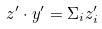Convert formula to latex. <formula><loc_0><loc_0><loc_500><loc_500>z ^ { \prime } \cdot y ^ { \prime } = \Sigma _ { i } z _ { i } ^ { \prime }</formula> 